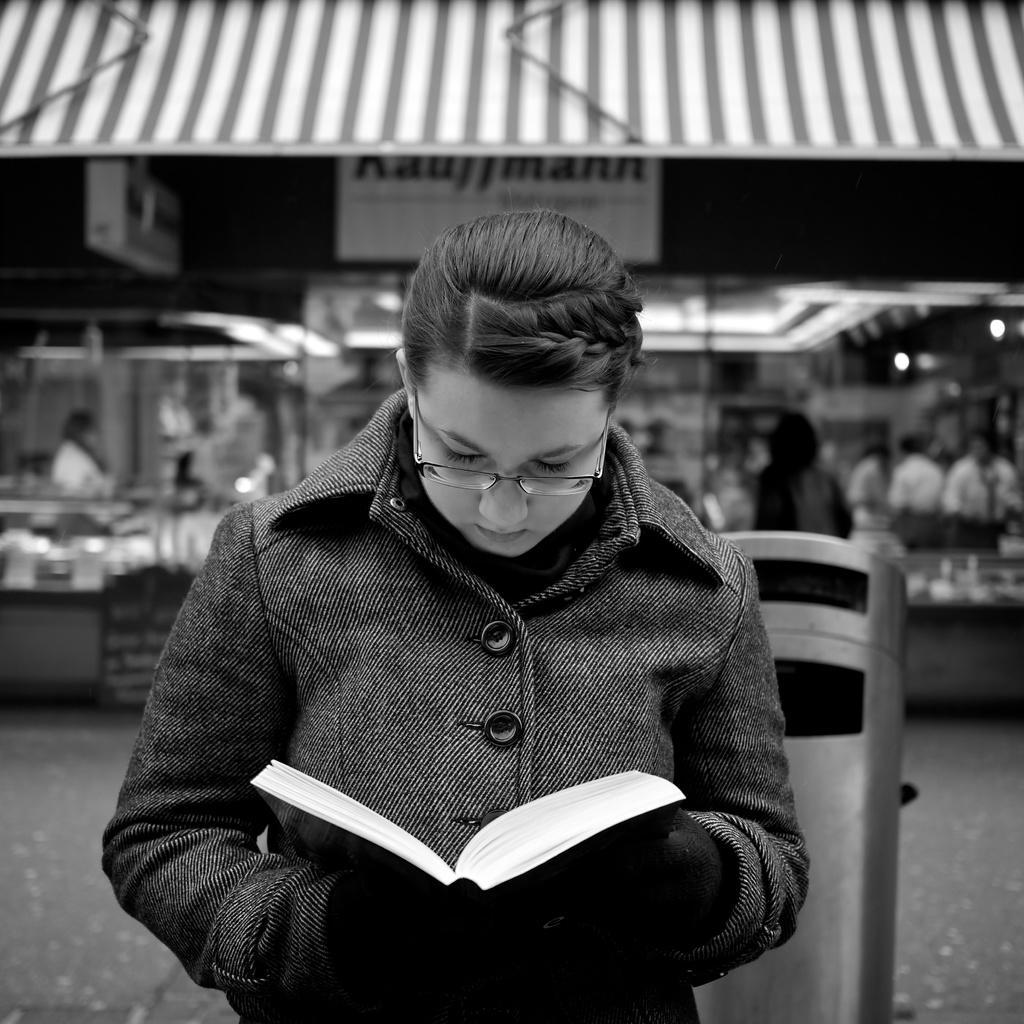Could you give a brief overview of what you see in this image? In this black and white image there is a lady standing and holding a book in her hand, behind her there is an object and a stall, few people are standing in front of the stall. 